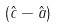<formula> <loc_0><loc_0><loc_500><loc_500>( { \hat { c } } - { \hat { a } } )</formula> 